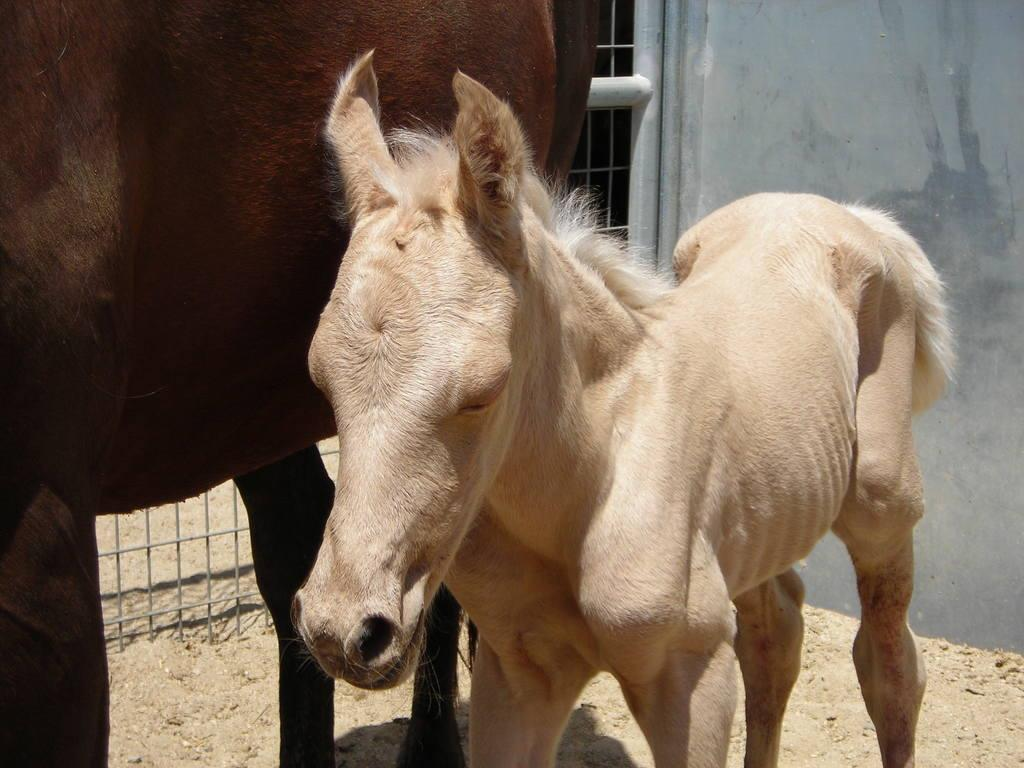What animals are present in the image? There are horses in the image. What type of terrain is visible at the bottom of the image? There is sand at the bottom of the image. What structure can be seen behind the horses? There is a gate behind the horses. What type of feature is located on the right side of the image? There is a well on the right side of the image. What type of waste can be seen being carried by the horses in the image? There is no waste being carried by the horses in the image; they are not depicted performing any labor or task. 